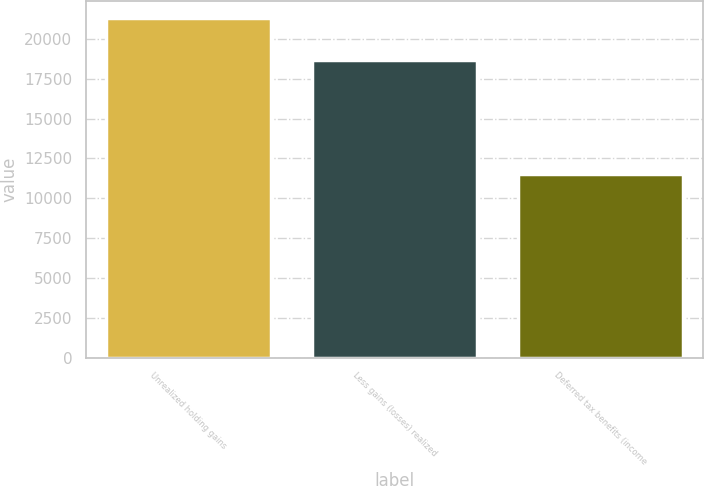Convert chart to OTSL. <chart><loc_0><loc_0><loc_500><loc_500><bar_chart><fcel>Unrealized holding gains<fcel>Less gains (losses) realized<fcel>Deferred tax benefits (income<nl><fcel>21348<fcel>18701<fcel>11512<nl></chart> 